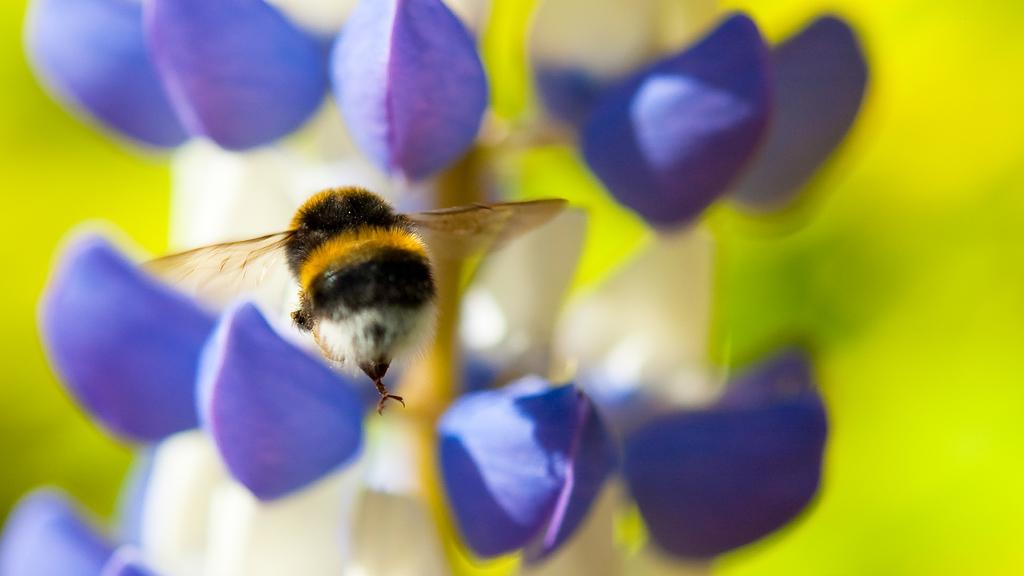What is the main subject of the image? There is a honey bee in the image. What is the honey bee doing in the image? The honey bee is flying in the air. What can be seen in the background of the image? There is a plant or a flower in the background of the image. What type of curtain can be seen hanging from the honey bee's wings in the image? There is no curtain present in the image, and the honey bee's wings do not have any curtains hanging from them. 